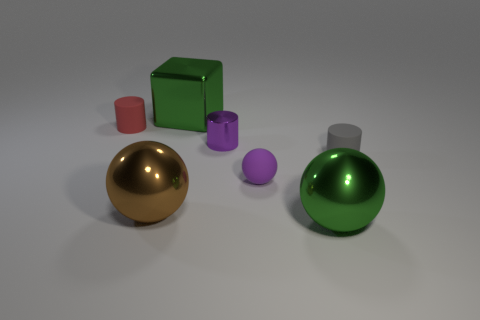Add 2 big brown metal objects. How many objects exist? 9 Subtract all cubes. How many objects are left? 6 Add 1 tiny matte spheres. How many tiny matte spheres exist? 2 Subtract 0 purple blocks. How many objects are left? 7 Subtract all gray objects. Subtract all tiny cylinders. How many objects are left? 3 Add 6 big shiny spheres. How many big shiny spheres are left? 8 